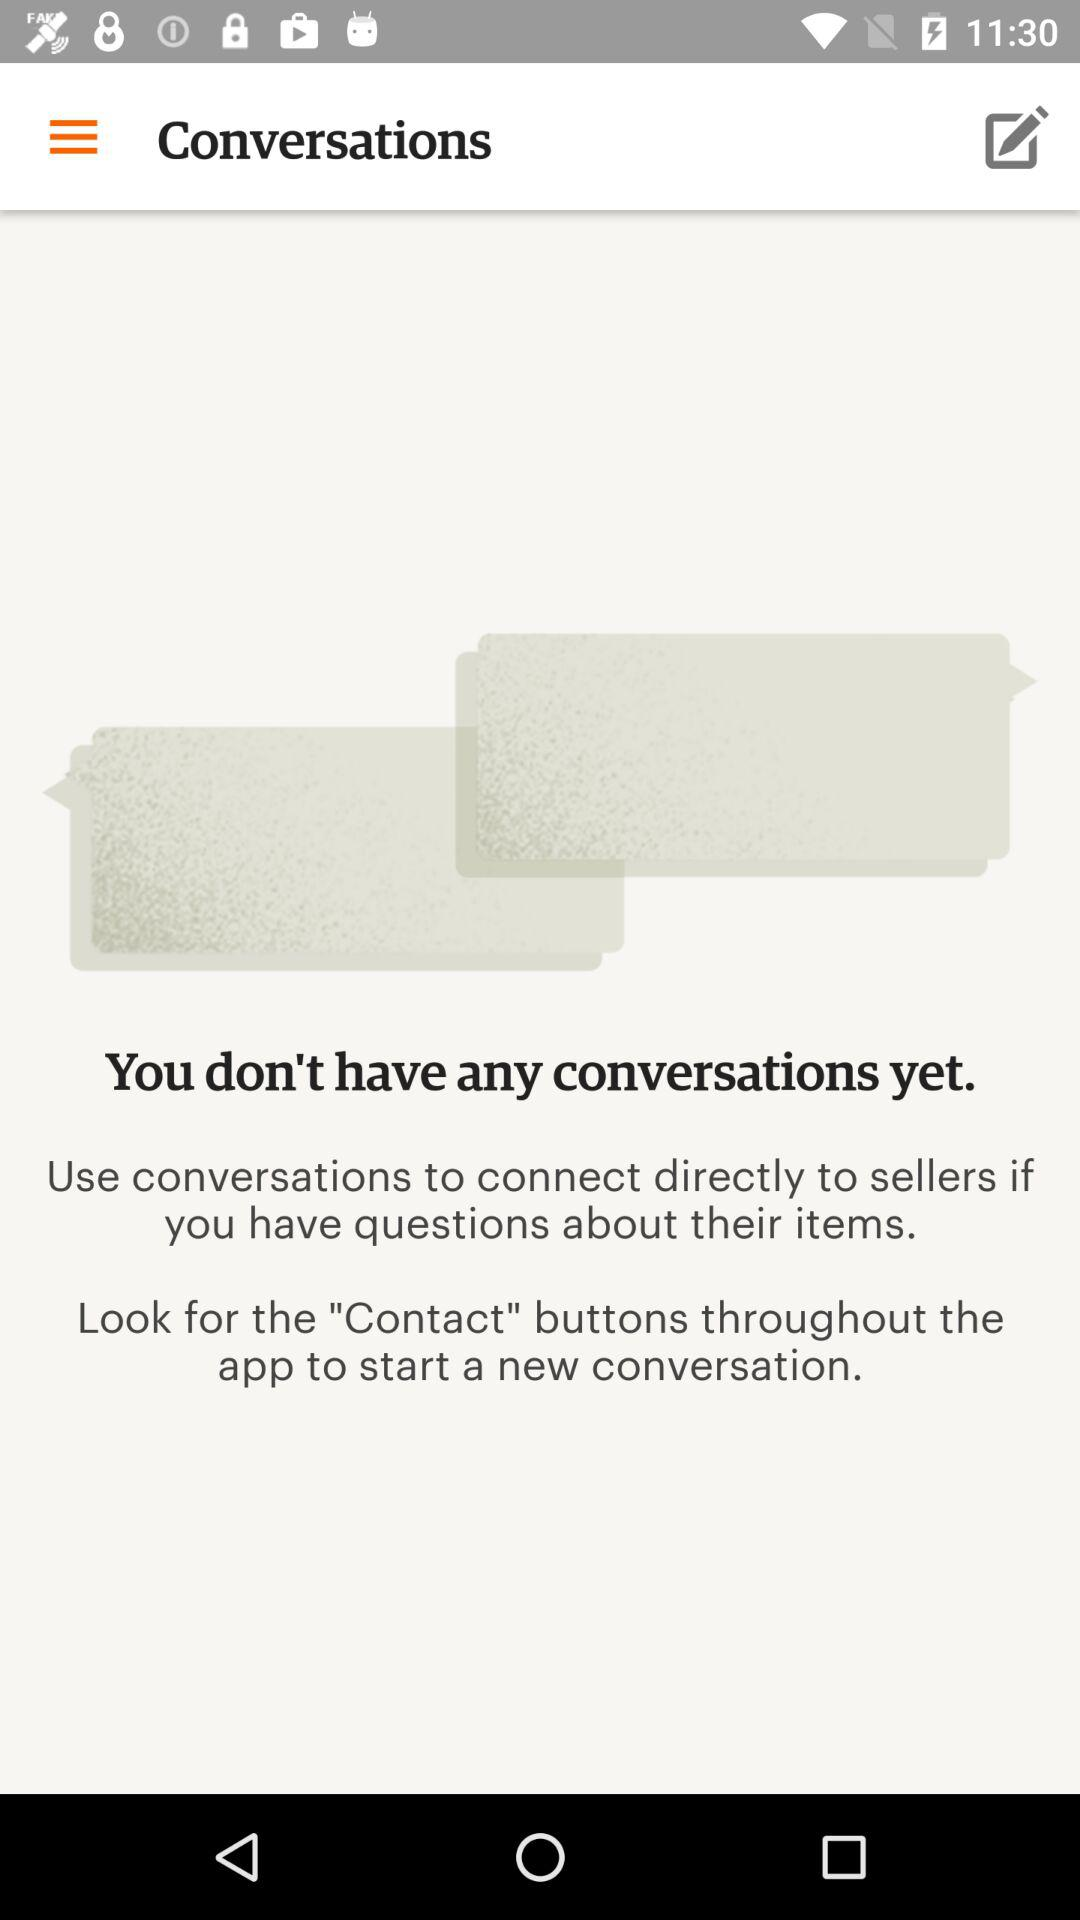How many conversations do I have?
Answer the question using a single word or phrase. 0 